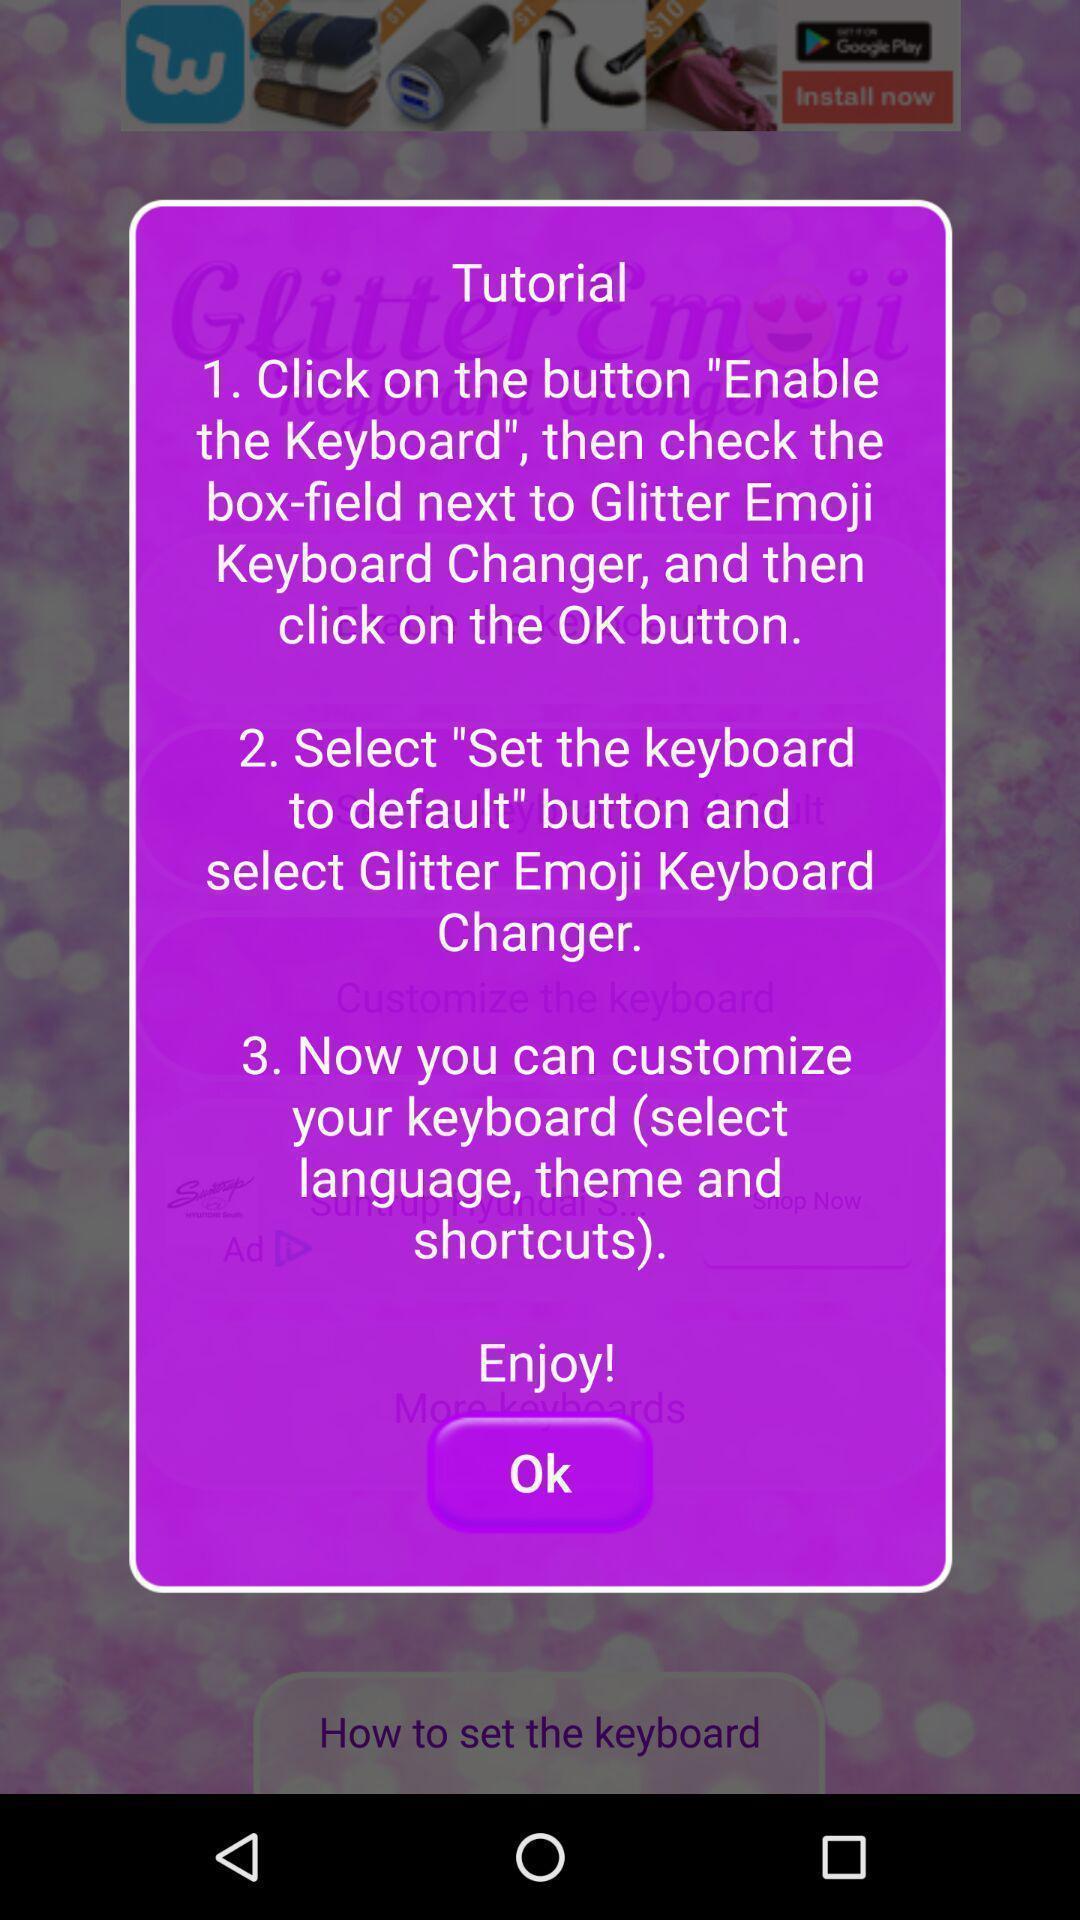Explain the elements present in this screenshot. Popup showing tutorial. 